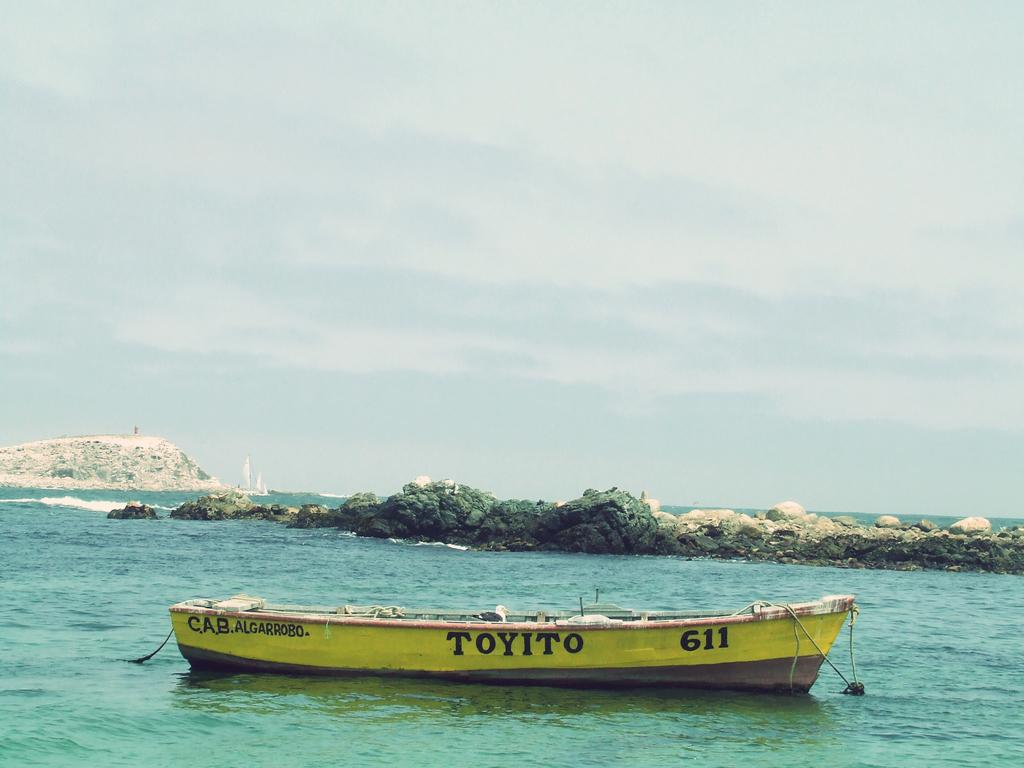What is the main subject of the image? The main subject of the image is a boat. Where is the boat located? The boat is on the water. What other natural elements can be seen in the image? There are rocks and a mountain visible in the image. What is visible in the background of the image? The sky is visible in the image. How many zebras are grazing on the mountain in the image? There are no zebras present in the image; it features a boat on the water with rocks and a mountain in the background. What type of pie is being served on the boat in the image? There is no pie visible in the image; it only shows a boat on the water with rocks, a mountain, and the sky in the background. 